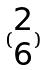Convert formula to latex. <formula><loc_0><loc_0><loc_500><loc_500>( \begin{matrix} 2 \\ 6 \end{matrix} )</formula> 